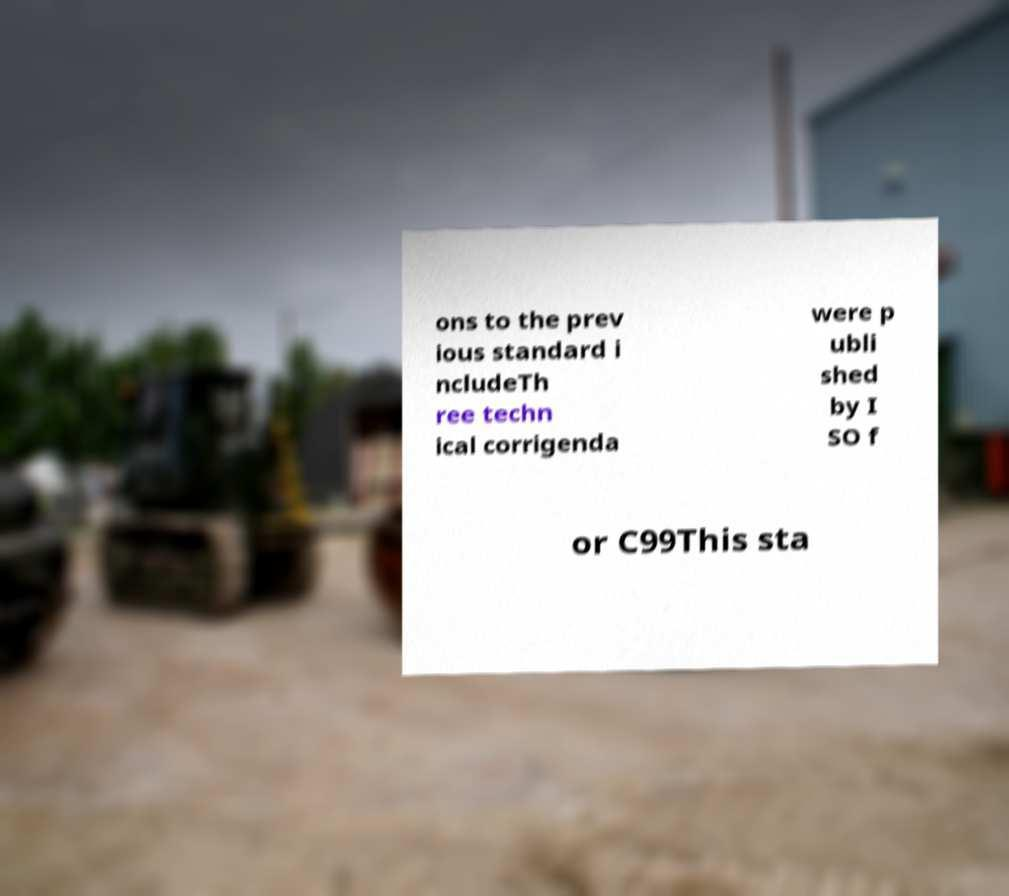Could you extract and type out the text from this image? ons to the prev ious standard i ncludeTh ree techn ical corrigenda were p ubli shed by I SO f or C99This sta 